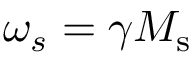<formula> <loc_0><loc_0><loc_500><loc_500>\omega _ { s } = \gamma M _ { s }</formula> 